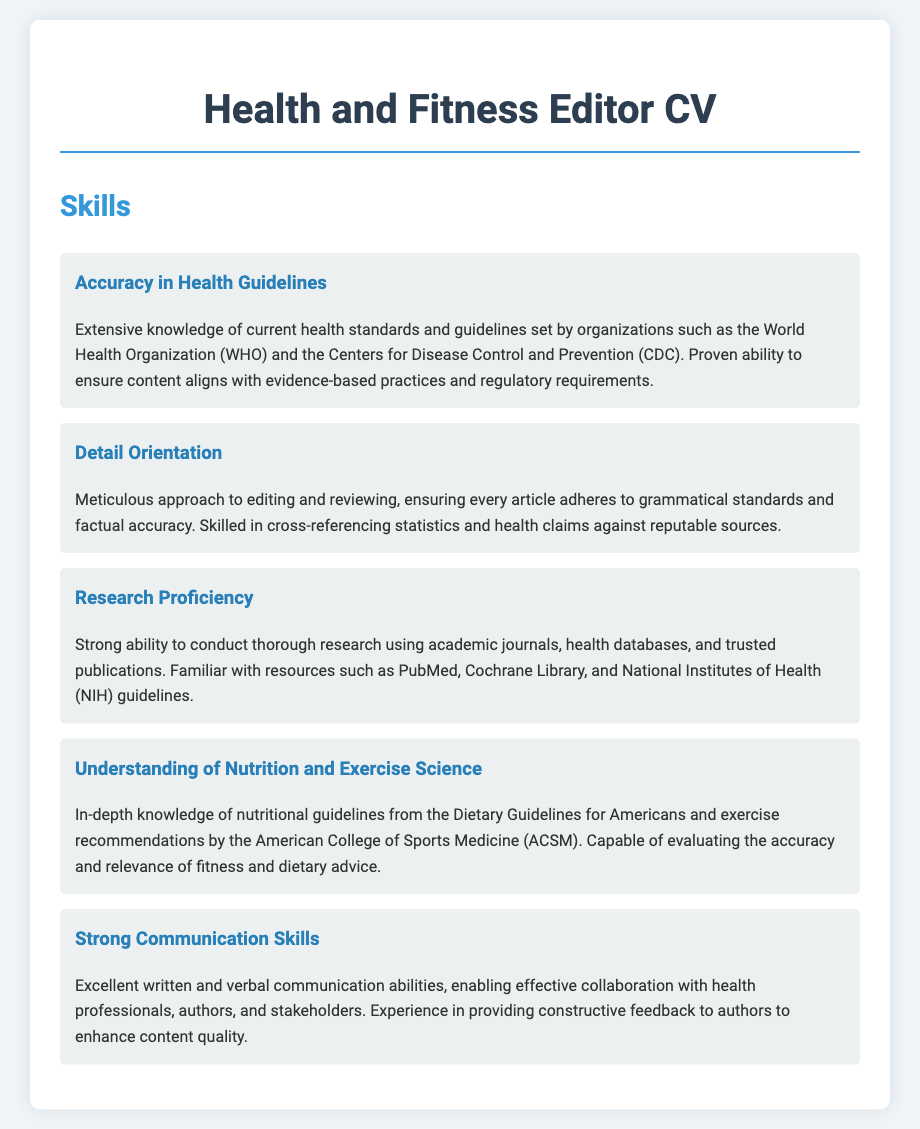what organization is referenced for health standards? The document mentions the World Health Organization (WHO) as one of the organizations that set health standards.
Answer: World Health Organization (WHO) what skill involves ensuring grammatical standards? The skill that involves ensuring grammatical standards is described under "Detail Orientation."
Answer: Detail Orientation how many organizations are specifically referenced in the skills section? The skills section references at least two organizations, namely WHO and CDC.
Answer: Two what does the editor provide to enhance content quality? The editor provides constructive feedback to authors to enhance content quality.
Answer: Constructive feedback which skill emphasizes research from trusted publications? The skill that emphasizes research from trusted publications is "Research Proficiency."
Answer: Research Proficiency what is the primary focus of the "Understanding of Nutrition and Exercise Science" skill? The primary focus of this skill is knowledge of nutritional guidelines and exercise recommendations.
Answer: Nutritional guidelines and exercise recommendations how does "Strong Communication Skills" benefit collaboration? This skill allows for effective collaboration with health professionals, authors, and stakeholders.
Answer: Effective collaboration what document element follows the skills section? The document element following the skills section is not specified in the code provided.
Answer: N/A how is provided feedback categorized in the skills section? The feedback provided is categorized as constructive feedback to enhance content quality.
Answer: Constructive feedback 